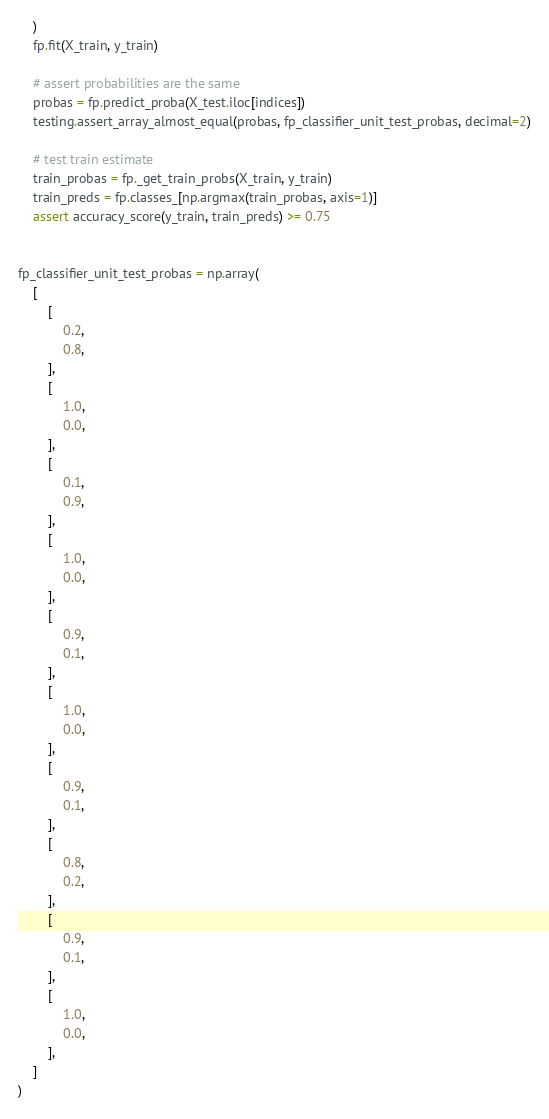Convert code to text. <code><loc_0><loc_0><loc_500><loc_500><_Python_>    )
    fp.fit(X_train, y_train)

    # assert probabilities are the same
    probas = fp.predict_proba(X_test.iloc[indices])
    testing.assert_array_almost_equal(probas, fp_classifier_unit_test_probas, decimal=2)

    # test train estimate
    train_probas = fp._get_train_probs(X_train, y_train)
    train_preds = fp.classes_[np.argmax(train_probas, axis=1)]
    assert accuracy_score(y_train, train_preds) >= 0.75


fp_classifier_unit_test_probas = np.array(
    [
        [
            0.2,
            0.8,
        ],
        [
            1.0,
            0.0,
        ],
        [
            0.1,
            0.9,
        ],
        [
            1.0,
            0.0,
        ],
        [
            0.9,
            0.1,
        ],
        [
            1.0,
            0.0,
        ],
        [
            0.9,
            0.1,
        ],
        [
            0.8,
            0.2,
        ],
        [
            0.9,
            0.1,
        ],
        [
            1.0,
            0.0,
        ],
    ]
)
</code> 